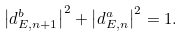Convert formula to latex. <formula><loc_0><loc_0><loc_500><loc_500>\left | { d } _ { E , n + 1 } ^ { b } \right | ^ { 2 } + \left | { d } _ { E , n } ^ { a } \right | ^ { 2 } = 1 .</formula> 